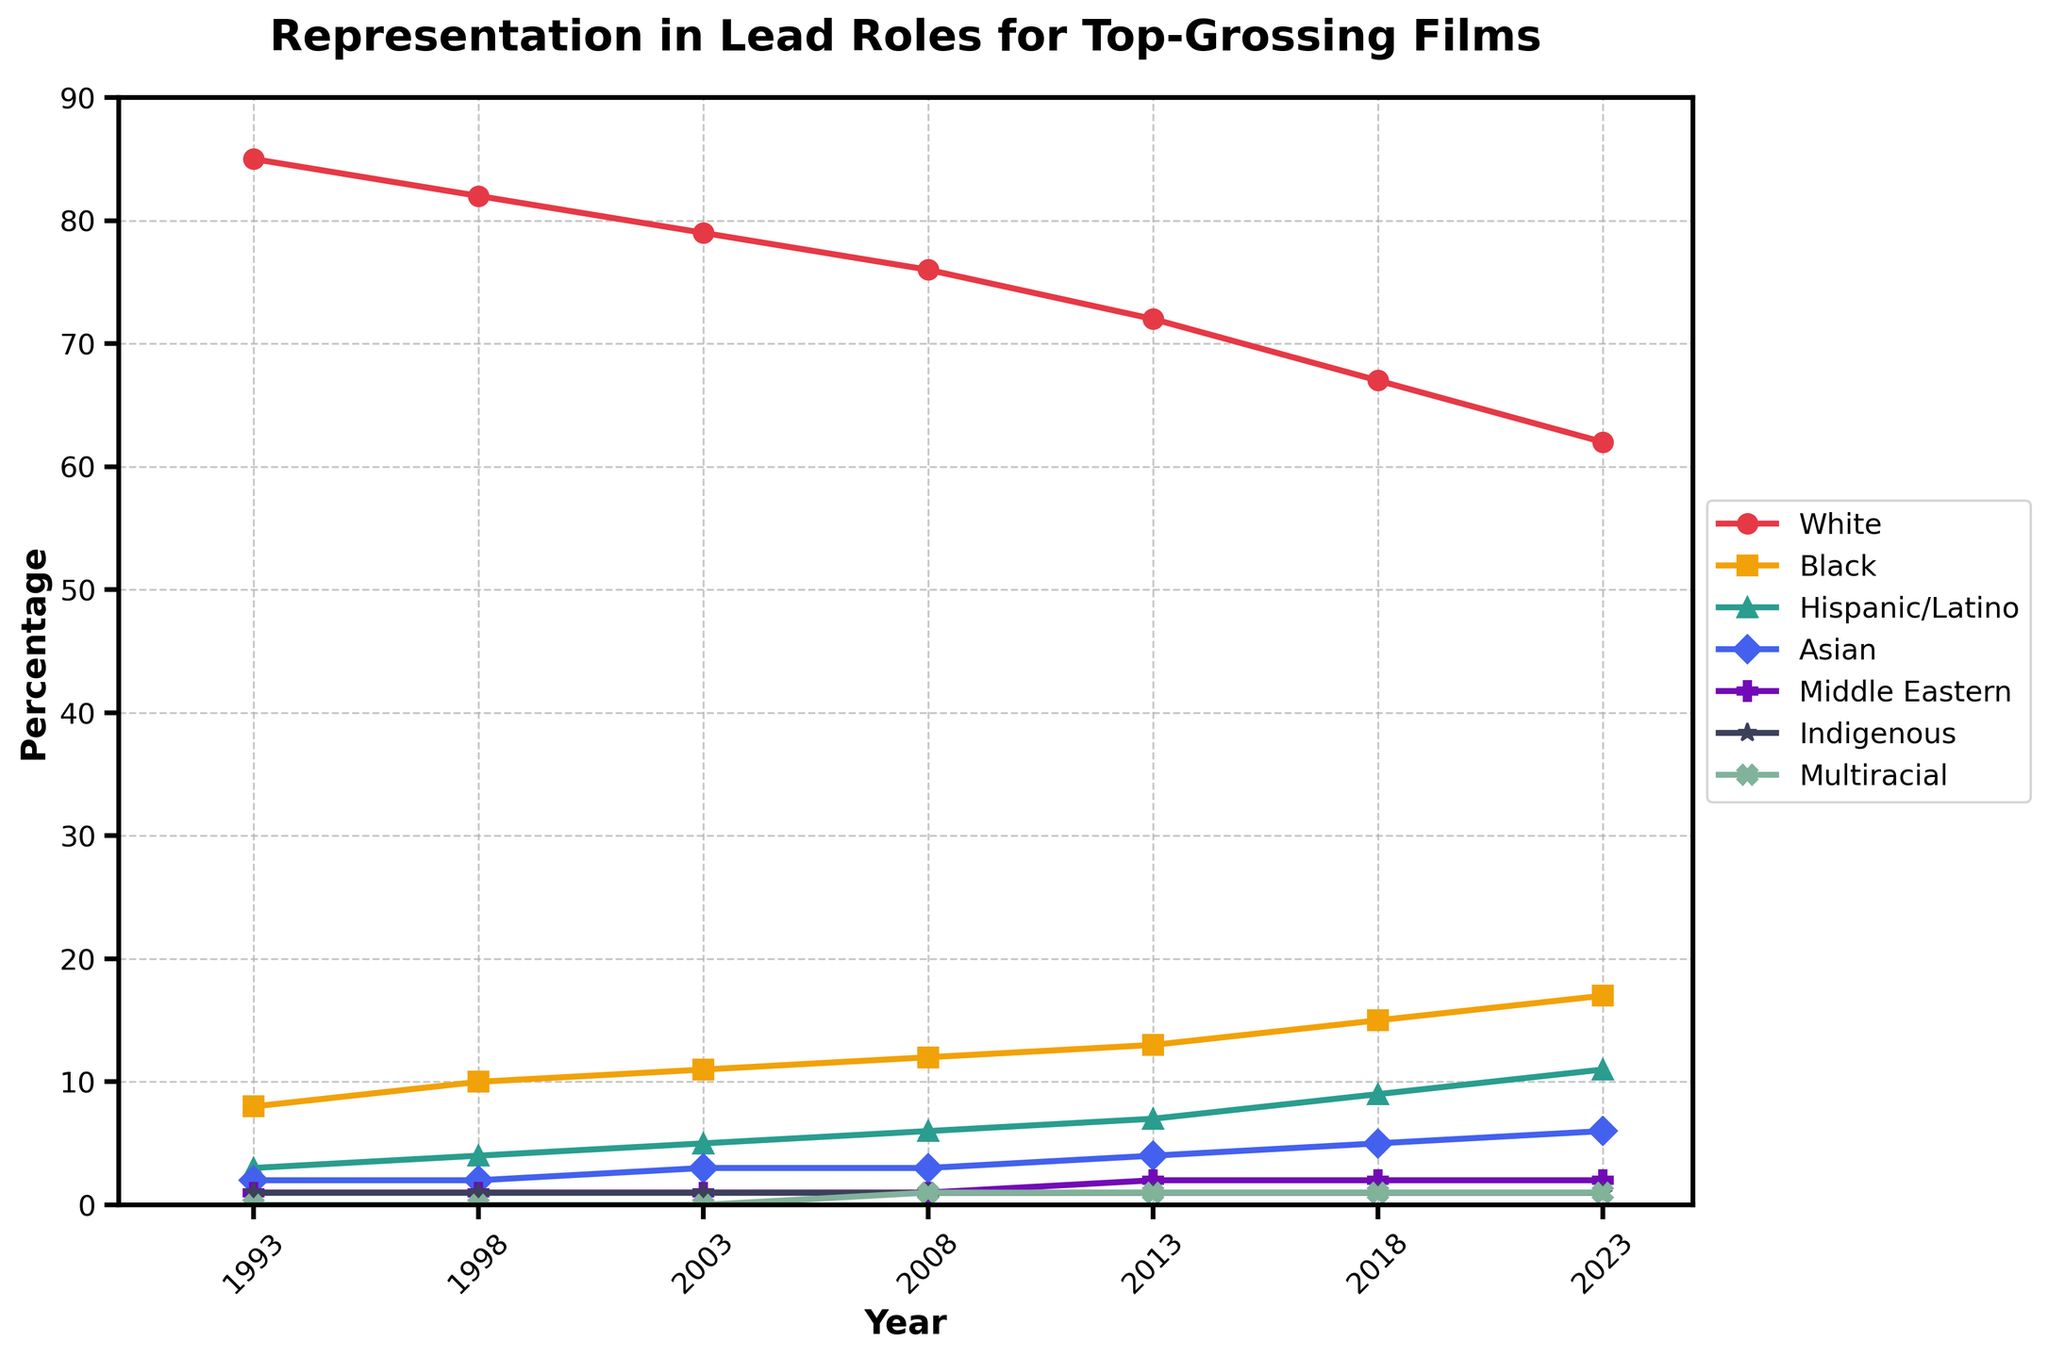How has the representation of White actors in lead roles changed from 1993 to 2023? To find out the change, subtract the percentage in 2023 from the percentage in 1993. So, 85 - 62 = 23.
Answer: Decreased by 23% Which ethnicity showed an increase in representation from 1993 to 2023, and by how much? Black actors had an increase in representation. Subtract the 1993 percentage from the 2023 percentage, which is 17 - 8 = 9.
Answer: Black, Increased by 9% Compare the representation of Hispanic/Latino actors and Asian actors in 2013. Which group had higher representation and by how much? Hispanic/Latino actors had 7% and Asian actors had 4%. The difference is 7 - 4 = 3.
Answer: Hispanic/Latino had higher representation by 3% What is the total representation percentage of all non-White ethnicities in 2018? Add the percentages of all non-White ethnicities: 15 + 9 + 5 + 2 + 1 + 1 = 33.
Answer: 33% In which year did Middle Eastern actors first show a measurable representation in lead roles? Looking at the data, the first year Middle Eastern actors show a measurable 1% representation is 2013.
Answer: 2013 What is the average representation of Indigenous actors from 1993 to 2023? Sum the representation percentages for Indigenous actors across all years and divide by the number of data points: (1+1+1+1+1+1+1)/7. This results in 7/7 = 1.
Answer: 1% Which year had the highest representation of Black actors, and what was the percentage? Scan the chart for the highest representation percentage for Black actors and note the year. The highest percentage is 17 in 2023.
Answer: 2023, 17% Compare the trends of White actors and Multiracial actors from 1993 to 2023. What do you observe? White actors show a decreasing trend throughout the years, while Multiracial actors first appear in 2008 and remain constant at 1%.
Answer: White actors' representation decreases, Multiracial actors remain constant at 1% In 2008, what was the combined representation of Black, Hispanic/Latino, and Asian actors? Add the percentages for Black, Hispanic/Latino, and Asian actors in 2008: 12 + 6 + 3 = 21.
Answer: 21% Was there any change in the representation of Hispanic/Latino actors from 1998 to 2003? Compare the percentages for Hispanic/Latino actors in 1998 and 2003. The values were 4% in 1998 and 5% in 2003, so there was an increase by 1%.
Answer: Increased by 1% 